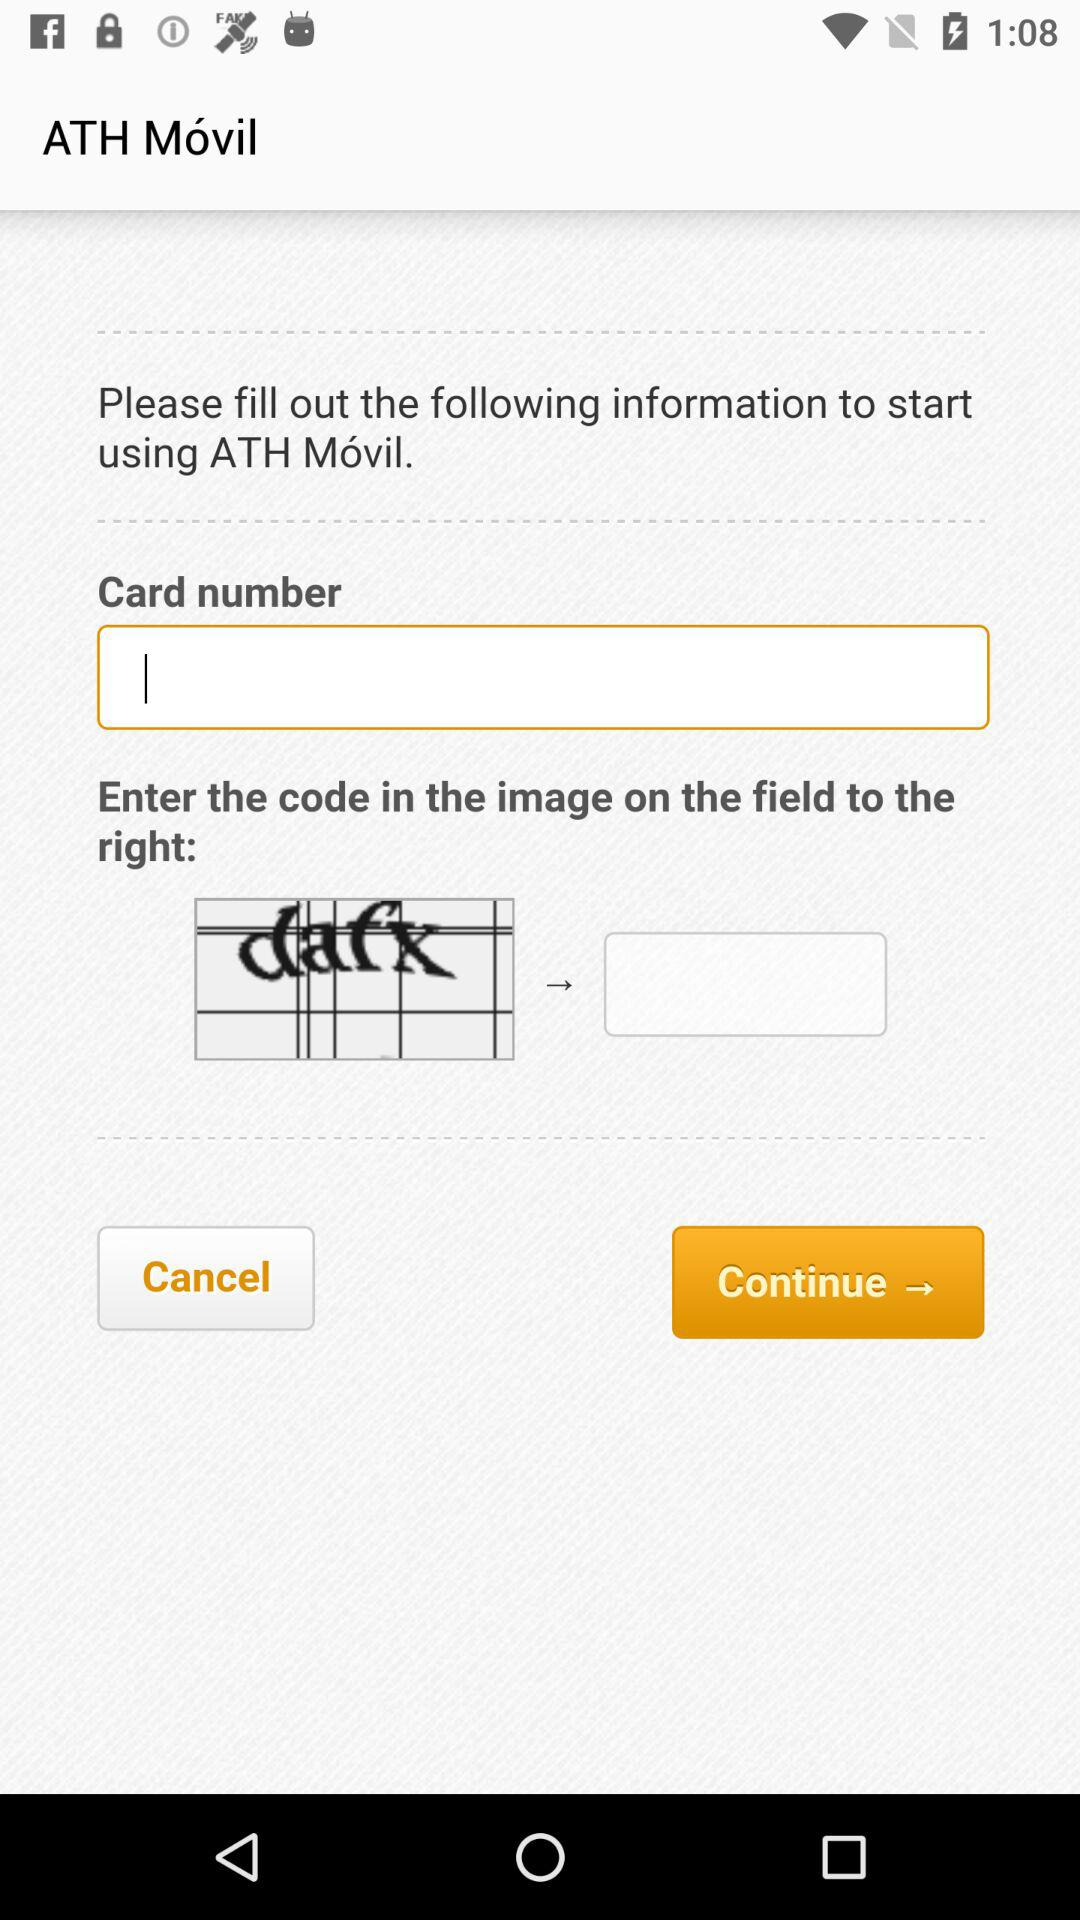What is the name of the application? The name of the application is "ATH Móvil". 